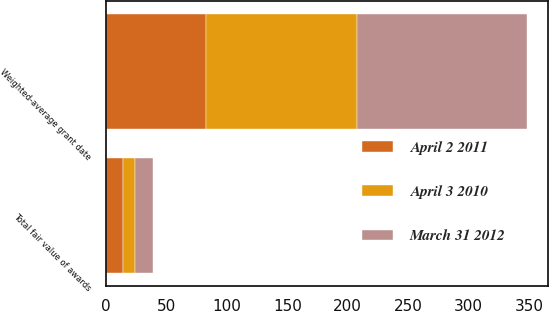Convert chart to OTSL. <chart><loc_0><loc_0><loc_500><loc_500><stacked_bar_chart><ecel><fcel>Weighted-average grant date<fcel>Total fair value of awards<nl><fcel>March 31 2012<fcel>140.86<fcel>14.8<nl><fcel>April 3 2010<fcel>125.26<fcel>9.8<nl><fcel>April 2 2011<fcel>82.47<fcel>14.2<nl></chart> 